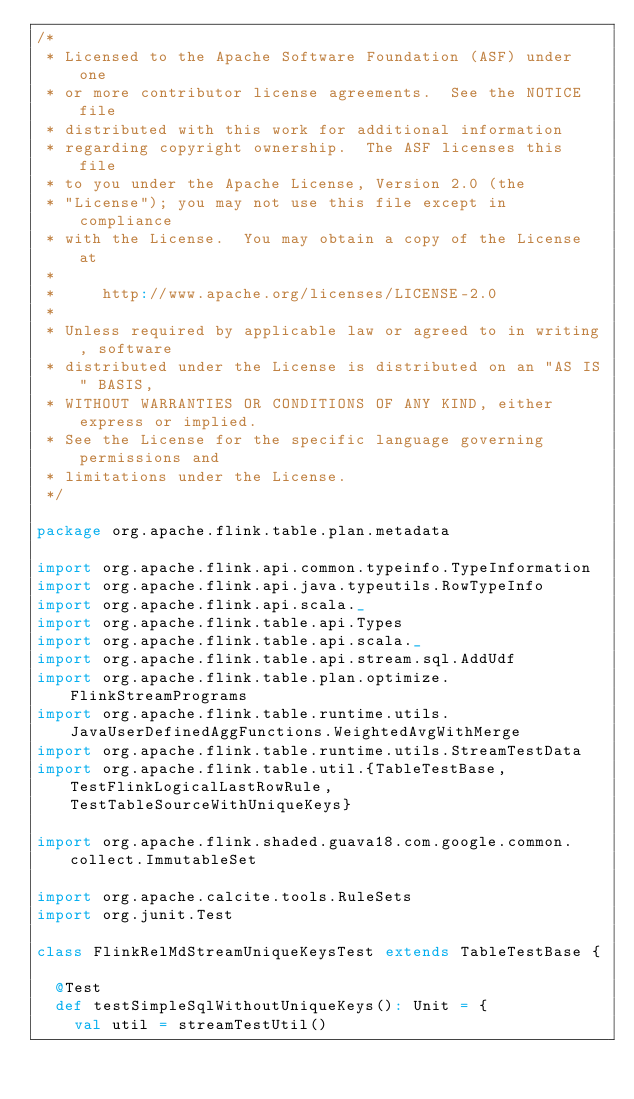<code> <loc_0><loc_0><loc_500><loc_500><_Scala_>/*
 * Licensed to the Apache Software Foundation (ASF) under one
 * or more contributor license agreements.  See the NOTICE file
 * distributed with this work for additional information
 * regarding copyright ownership.  The ASF licenses this file
 * to you under the Apache License, Version 2.0 (the
 * "License"); you may not use this file except in compliance
 * with the License.  You may obtain a copy of the License at
 *
 *     http://www.apache.org/licenses/LICENSE-2.0
 *
 * Unless required by applicable law or agreed to in writing, software
 * distributed under the License is distributed on an "AS IS" BASIS,
 * WITHOUT WARRANTIES OR CONDITIONS OF ANY KIND, either express or implied.
 * See the License for the specific language governing permissions and
 * limitations under the License.
 */

package org.apache.flink.table.plan.metadata

import org.apache.flink.api.common.typeinfo.TypeInformation
import org.apache.flink.api.java.typeutils.RowTypeInfo
import org.apache.flink.api.scala._
import org.apache.flink.table.api.Types
import org.apache.flink.table.api.scala._
import org.apache.flink.table.api.stream.sql.AddUdf
import org.apache.flink.table.plan.optimize.FlinkStreamPrograms
import org.apache.flink.table.runtime.utils.JavaUserDefinedAggFunctions.WeightedAvgWithMerge
import org.apache.flink.table.runtime.utils.StreamTestData
import org.apache.flink.table.util.{TableTestBase, TestFlinkLogicalLastRowRule, TestTableSourceWithUniqueKeys}

import org.apache.flink.shaded.guava18.com.google.common.collect.ImmutableSet

import org.apache.calcite.tools.RuleSets
import org.junit.Test

class FlinkRelMdStreamUniqueKeysTest extends TableTestBase {

  @Test
  def testSimpleSqlWithoutUniqueKeys(): Unit = {
    val util = streamTestUtil()</code> 